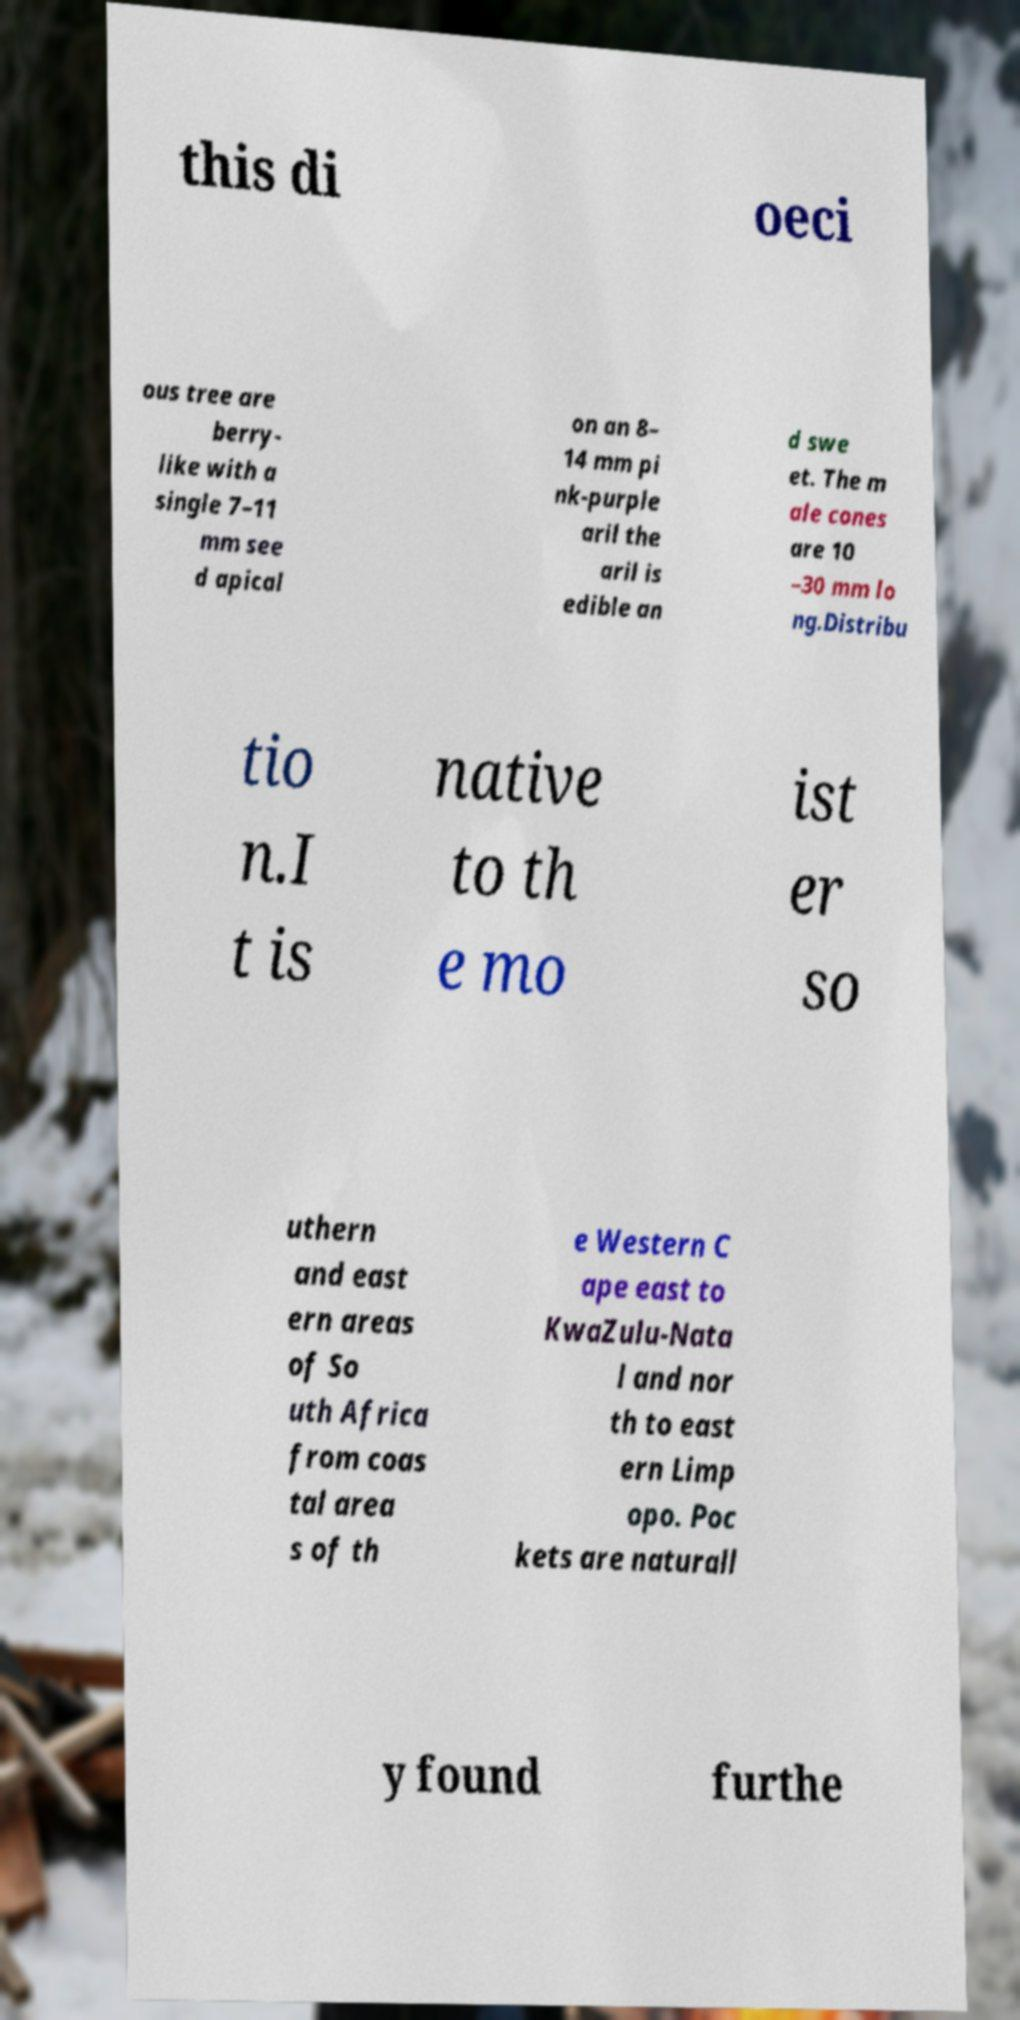I need the written content from this picture converted into text. Can you do that? this di oeci ous tree are berry- like with a single 7–11 mm see d apical on an 8– 14 mm pi nk-purple aril the aril is edible an d swe et. The m ale cones are 10 –30 mm lo ng.Distribu tio n.I t is native to th e mo ist er so uthern and east ern areas of So uth Africa from coas tal area s of th e Western C ape east to KwaZulu-Nata l and nor th to east ern Limp opo. Poc kets are naturall y found furthe 